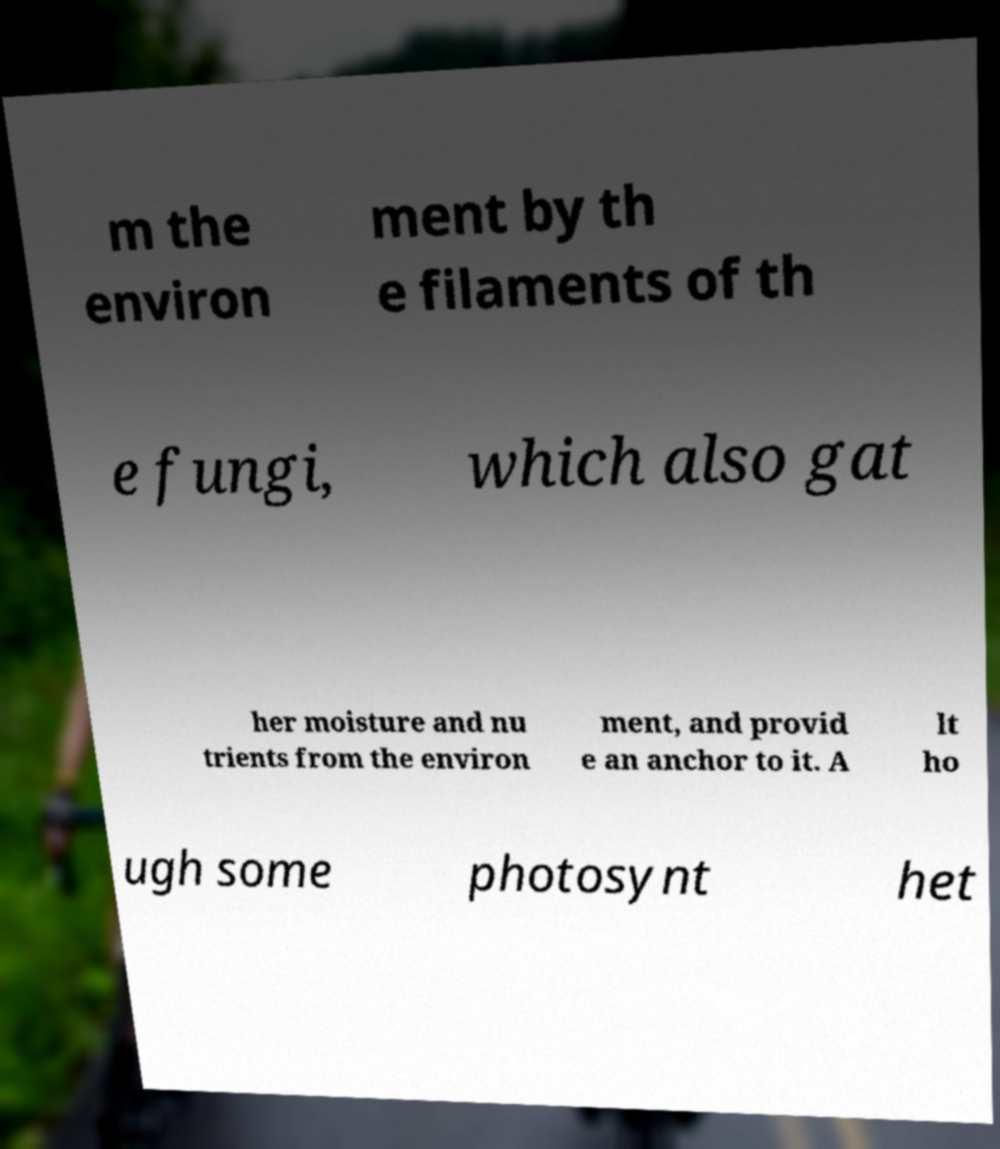Please read and relay the text visible in this image. What does it say? m the environ ment by th e filaments of th e fungi, which also gat her moisture and nu trients from the environ ment, and provid e an anchor to it. A lt ho ugh some photosynt het 